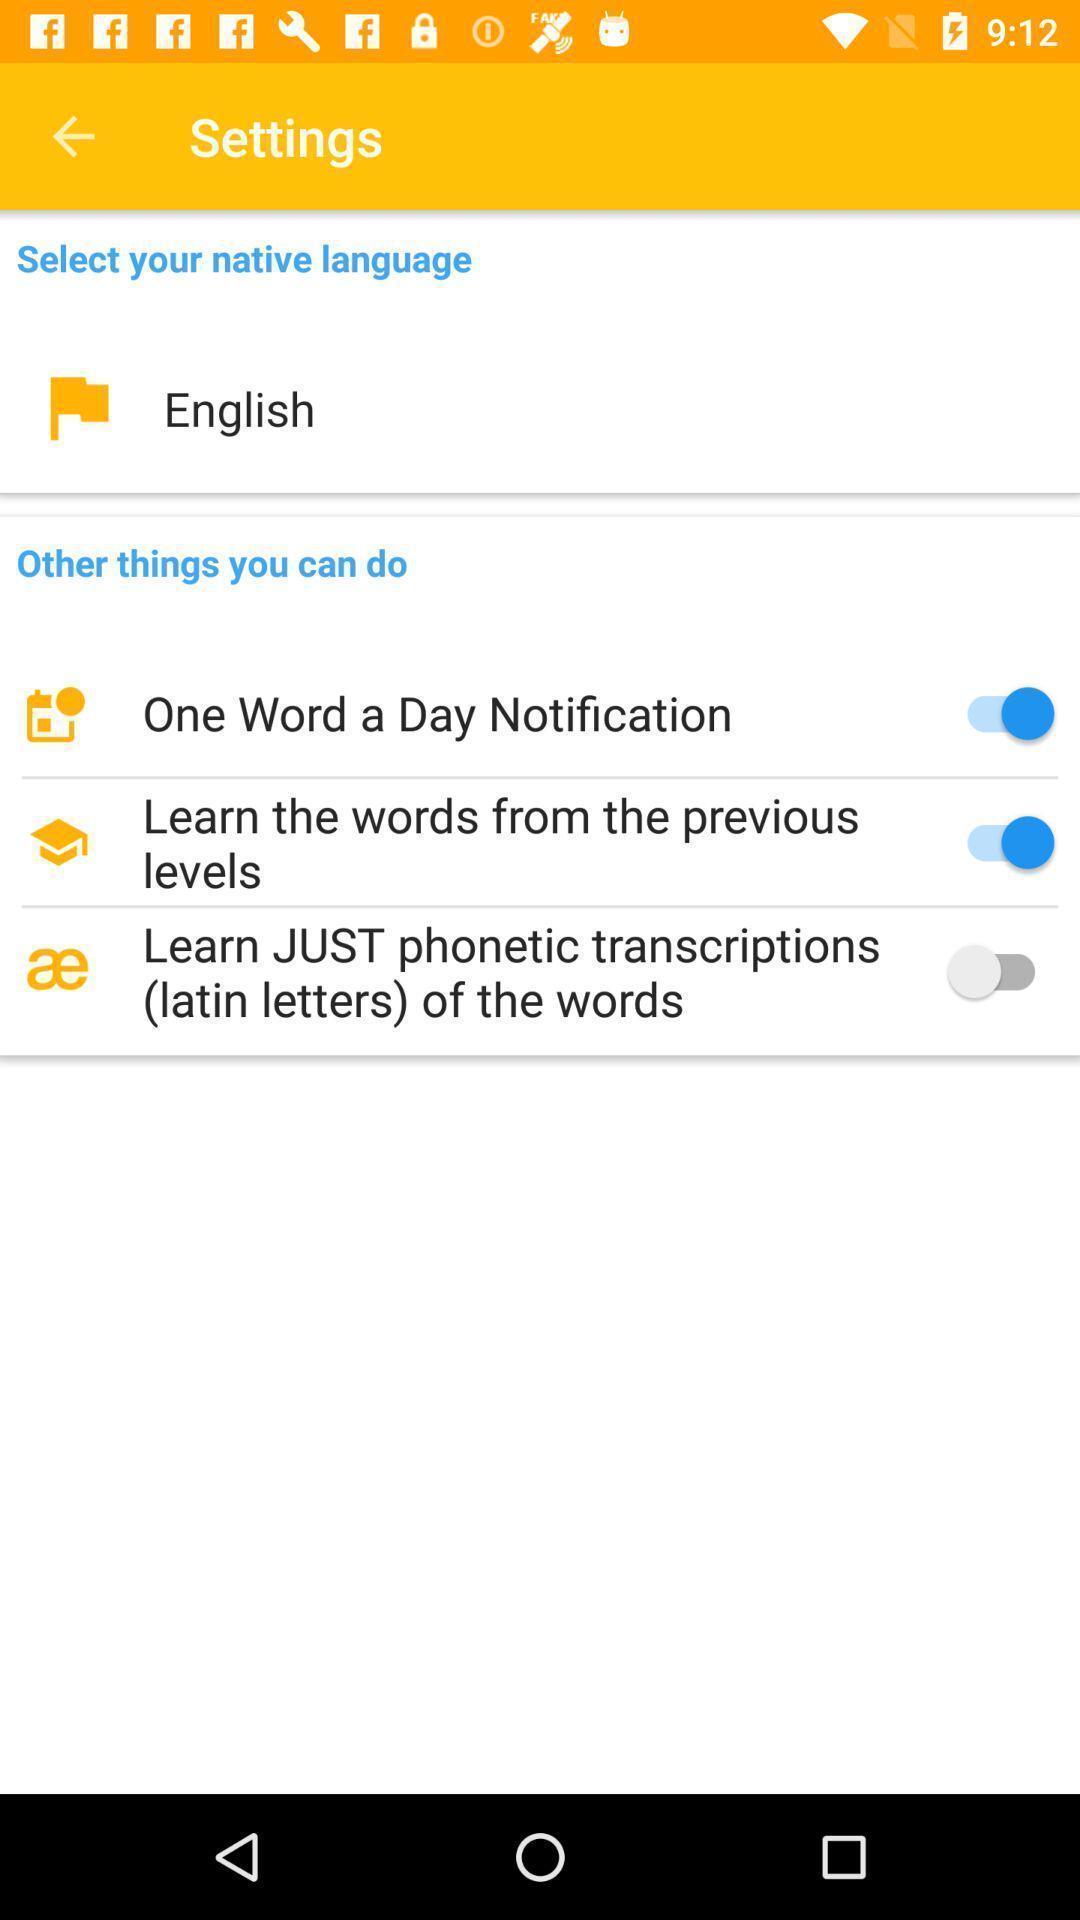Tell me about the visual elements in this screen capture. Settings page. 